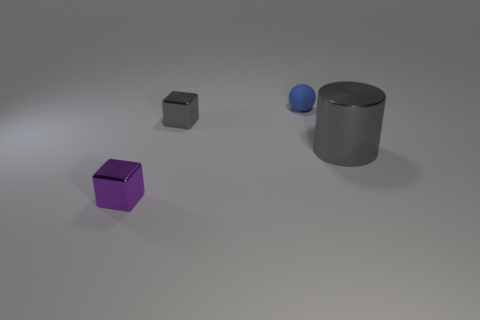Subtract 1 blocks. How many blocks are left? 1 Add 4 small metallic blocks. How many objects exist? 8 Subtract all balls. How many objects are left? 3 Subtract all gray shiny objects. Subtract all tiny purple metal blocks. How many objects are left? 1 Add 4 small purple objects. How many small purple objects are left? 5 Add 1 cyan rubber cubes. How many cyan rubber cubes exist? 1 Subtract 0 green cylinders. How many objects are left? 4 